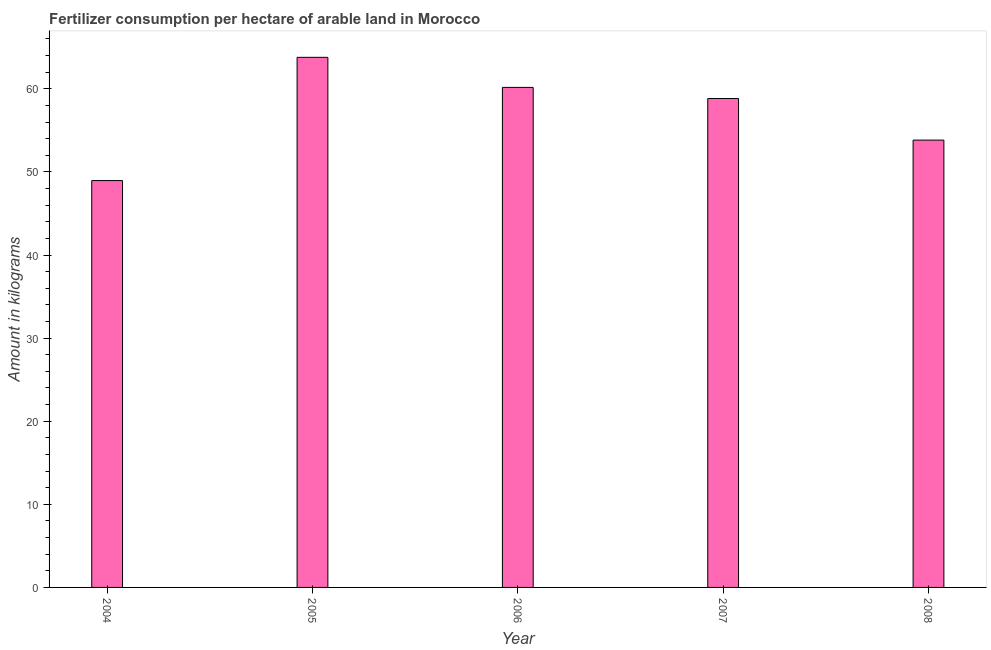Does the graph contain any zero values?
Offer a very short reply. No. Does the graph contain grids?
Give a very brief answer. No. What is the title of the graph?
Your answer should be very brief. Fertilizer consumption per hectare of arable land in Morocco . What is the label or title of the X-axis?
Give a very brief answer. Year. What is the label or title of the Y-axis?
Your answer should be very brief. Amount in kilograms. What is the amount of fertilizer consumption in 2007?
Keep it short and to the point. 58.83. Across all years, what is the maximum amount of fertilizer consumption?
Your answer should be very brief. 63.79. Across all years, what is the minimum amount of fertilizer consumption?
Provide a short and direct response. 48.96. What is the sum of the amount of fertilizer consumption?
Your answer should be very brief. 285.57. What is the difference between the amount of fertilizer consumption in 2007 and 2008?
Make the answer very short. 5. What is the average amount of fertilizer consumption per year?
Offer a terse response. 57.11. What is the median amount of fertilizer consumption?
Keep it short and to the point. 58.83. What is the ratio of the amount of fertilizer consumption in 2004 to that in 2008?
Your response must be concise. 0.91. Is the difference between the amount of fertilizer consumption in 2007 and 2008 greater than the difference between any two years?
Offer a very short reply. No. What is the difference between the highest and the second highest amount of fertilizer consumption?
Ensure brevity in your answer.  3.62. Is the sum of the amount of fertilizer consumption in 2004 and 2005 greater than the maximum amount of fertilizer consumption across all years?
Make the answer very short. Yes. What is the difference between the highest and the lowest amount of fertilizer consumption?
Your answer should be very brief. 14.83. In how many years, is the amount of fertilizer consumption greater than the average amount of fertilizer consumption taken over all years?
Your answer should be compact. 3. How many bars are there?
Offer a very short reply. 5. Are all the bars in the graph horizontal?
Your answer should be very brief. No. What is the difference between two consecutive major ticks on the Y-axis?
Your answer should be very brief. 10. What is the Amount in kilograms in 2004?
Your answer should be very brief. 48.96. What is the Amount in kilograms in 2005?
Provide a succinct answer. 63.79. What is the Amount in kilograms in 2006?
Keep it short and to the point. 60.17. What is the Amount in kilograms of 2007?
Give a very brief answer. 58.83. What is the Amount in kilograms in 2008?
Your answer should be very brief. 53.83. What is the difference between the Amount in kilograms in 2004 and 2005?
Offer a very short reply. -14.83. What is the difference between the Amount in kilograms in 2004 and 2006?
Keep it short and to the point. -11.21. What is the difference between the Amount in kilograms in 2004 and 2007?
Your answer should be very brief. -9.87. What is the difference between the Amount in kilograms in 2004 and 2008?
Make the answer very short. -4.87. What is the difference between the Amount in kilograms in 2005 and 2006?
Provide a short and direct response. 3.62. What is the difference between the Amount in kilograms in 2005 and 2007?
Make the answer very short. 4.96. What is the difference between the Amount in kilograms in 2005 and 2008?
Your answer should be very brief. 9.96. What is the difference between the Amount in kilograms in 2006 and 2007?
Offer a very short reply. 1.34. What is the difference between the Amount in kilograms in 2006 and 2008?
Provide a succinct answer. 6.34. What is the difference between the Amount in kilograms in 2007 and 2008?
Ensure brevity in your answer.  5. What is the ratio of the Amount in kilograms in 2004 to that in 2005?
Provide a short and direct response. 0.77. What is the ratio of the Amount in kilograms in 2004 to that in 2006?
Give a very brief answer. 0.81. What is the ratio of the Amount in kilograms in 2004 to that in 2007?
Your answer should be compact. 0.83. What is the ratio of the Amount in kilograms in 2004 to that in 2008?
Your response must be concise. 0.91. What is the ratio of the Amount in kilograms in 2005 to that in 2006?
Your response must be concise. 1.06. What is the ratio of the Amount in kilograms in 2005 to that in 2007?
Provide a short and direct response. 1.08. What is the ratio of the Amount in kilograms in 2005 to that in 2008?
Your answer should be compact. 1.19. What is the ratio of the Amount in kilograms in 2006 to that in 2008?
Your response must be concise. 1.12. What is the ratio of the Amount in kilograms in 2007 to that in 2008?
Your answer should be very brief. 1.09. 